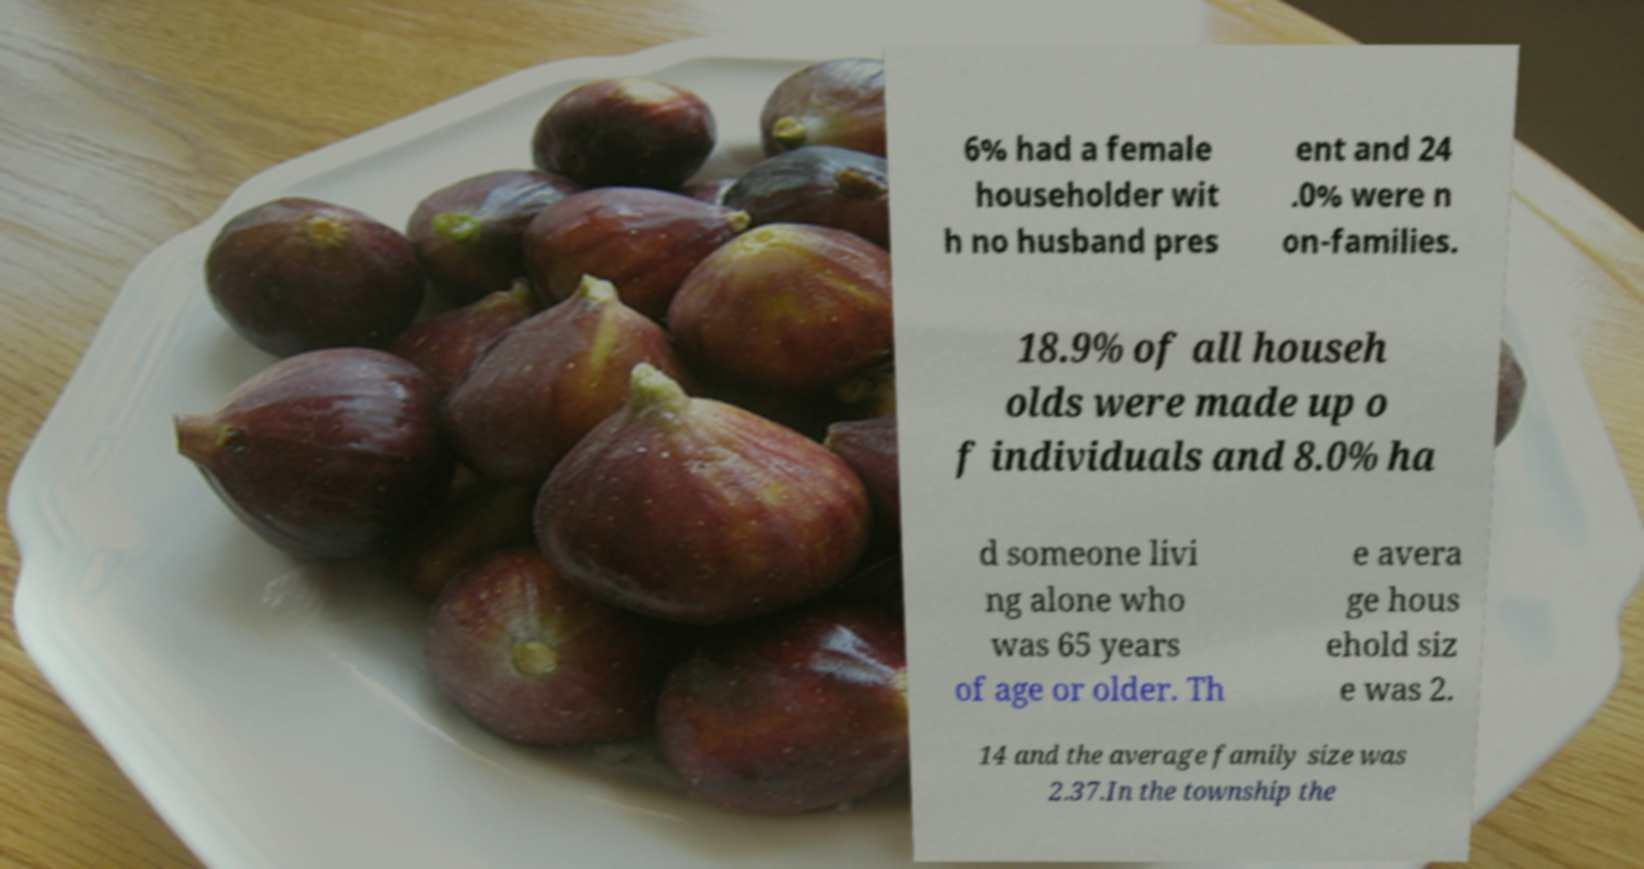I need the written content from this picture converted into text. Can you do that? 6% had a female householder wit h no husband pres ent and 24 .0% were n on-families. 18.9% of all househ olds were made up o f individuals and 8.0% ha d someone livi ng alone who was 65 years of age or older. Th e avera ge hous ehold siz e was 2. 14 and the average family size was 2.37.In the township the 